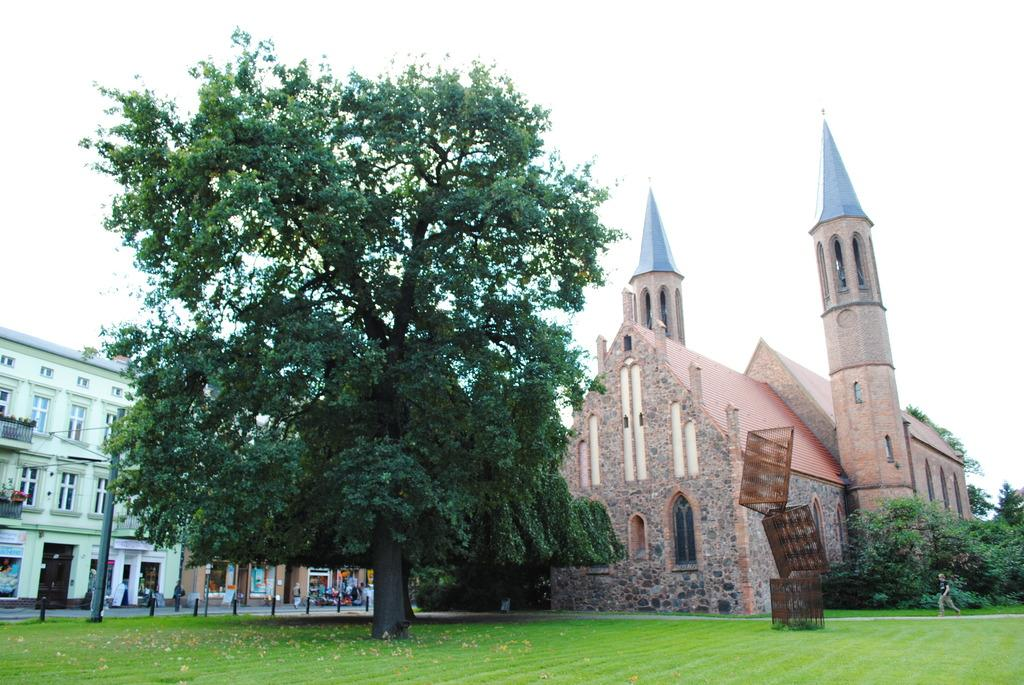What type of vegetation can be seen in the image? There is grass in the image. What other natural elements are present in the image? There are trees in the image. What man-made structures can be seen in the image? There are poles, buildings with windows, and objects in the image. Are there any people in the image? Yes, there are people in the image. What is visible in the background of the image? The sky is visible in the background of the image. Is there a playground visible in the image? There is no playground present in the image. Is it raining in the image? There is no indication of rain in the image; the sky is visible in the background, but no rain is depicted. 